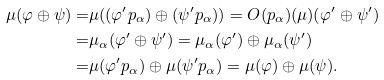<formula> <loc_0><loc_0><loc_500><loc_500>\mu ( \varphi \oplus \psi ) = & \mu ( ( \varphi ^ { \prime } p _ { \alpha } ) \oplus ( \psi ^ { \prime } p _ { \alpha } ) ) = O ( p _ { \alpha } ) ( \mu ) ( \varphi ^ { \prime } \oplus \psi ^ { \prime } ) \\ = & \mu _ { \alpha } ( \varphi ^ { \prime } \oplus \psi ^ { \prime } ) = \mu _ { \alpha } ( \varphi ^ { \prime } ) \oplus \mu _ { \alpha } ( \psi ^ { \prime } ) \\ = & \mu ( \varphi ^ { \prime } p _ { \alpha } ) \oplus \mu ( \psi ^ { \prime } p _ { \alpha } ) = \mu ( \varphi ) \oplus \mu ( \psi ) .</formula> 